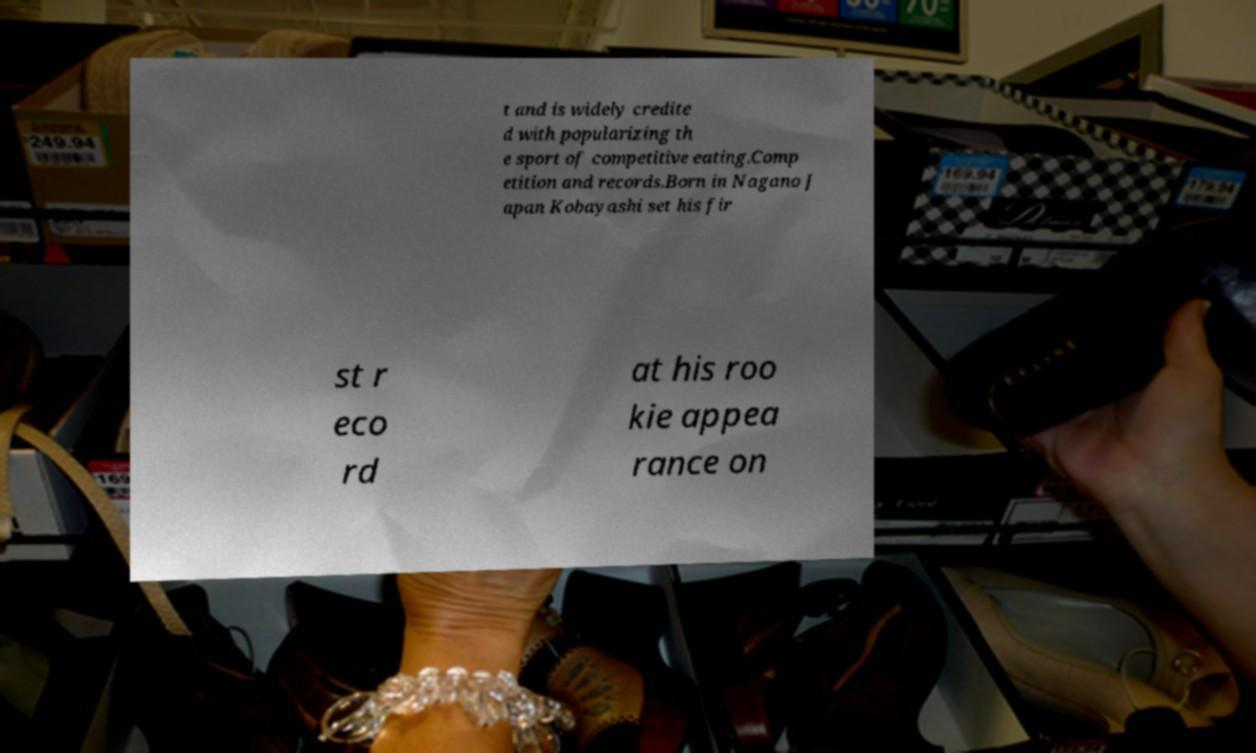Could you assist in decoding the text presented in this image and type it out clearly? t and is widely credite d with popularizing th e sport of competitive eating.Comp etition and records.Born in Nagano J apan Kobayashi set his fir st r eco rd at his roo kie appea rance on 